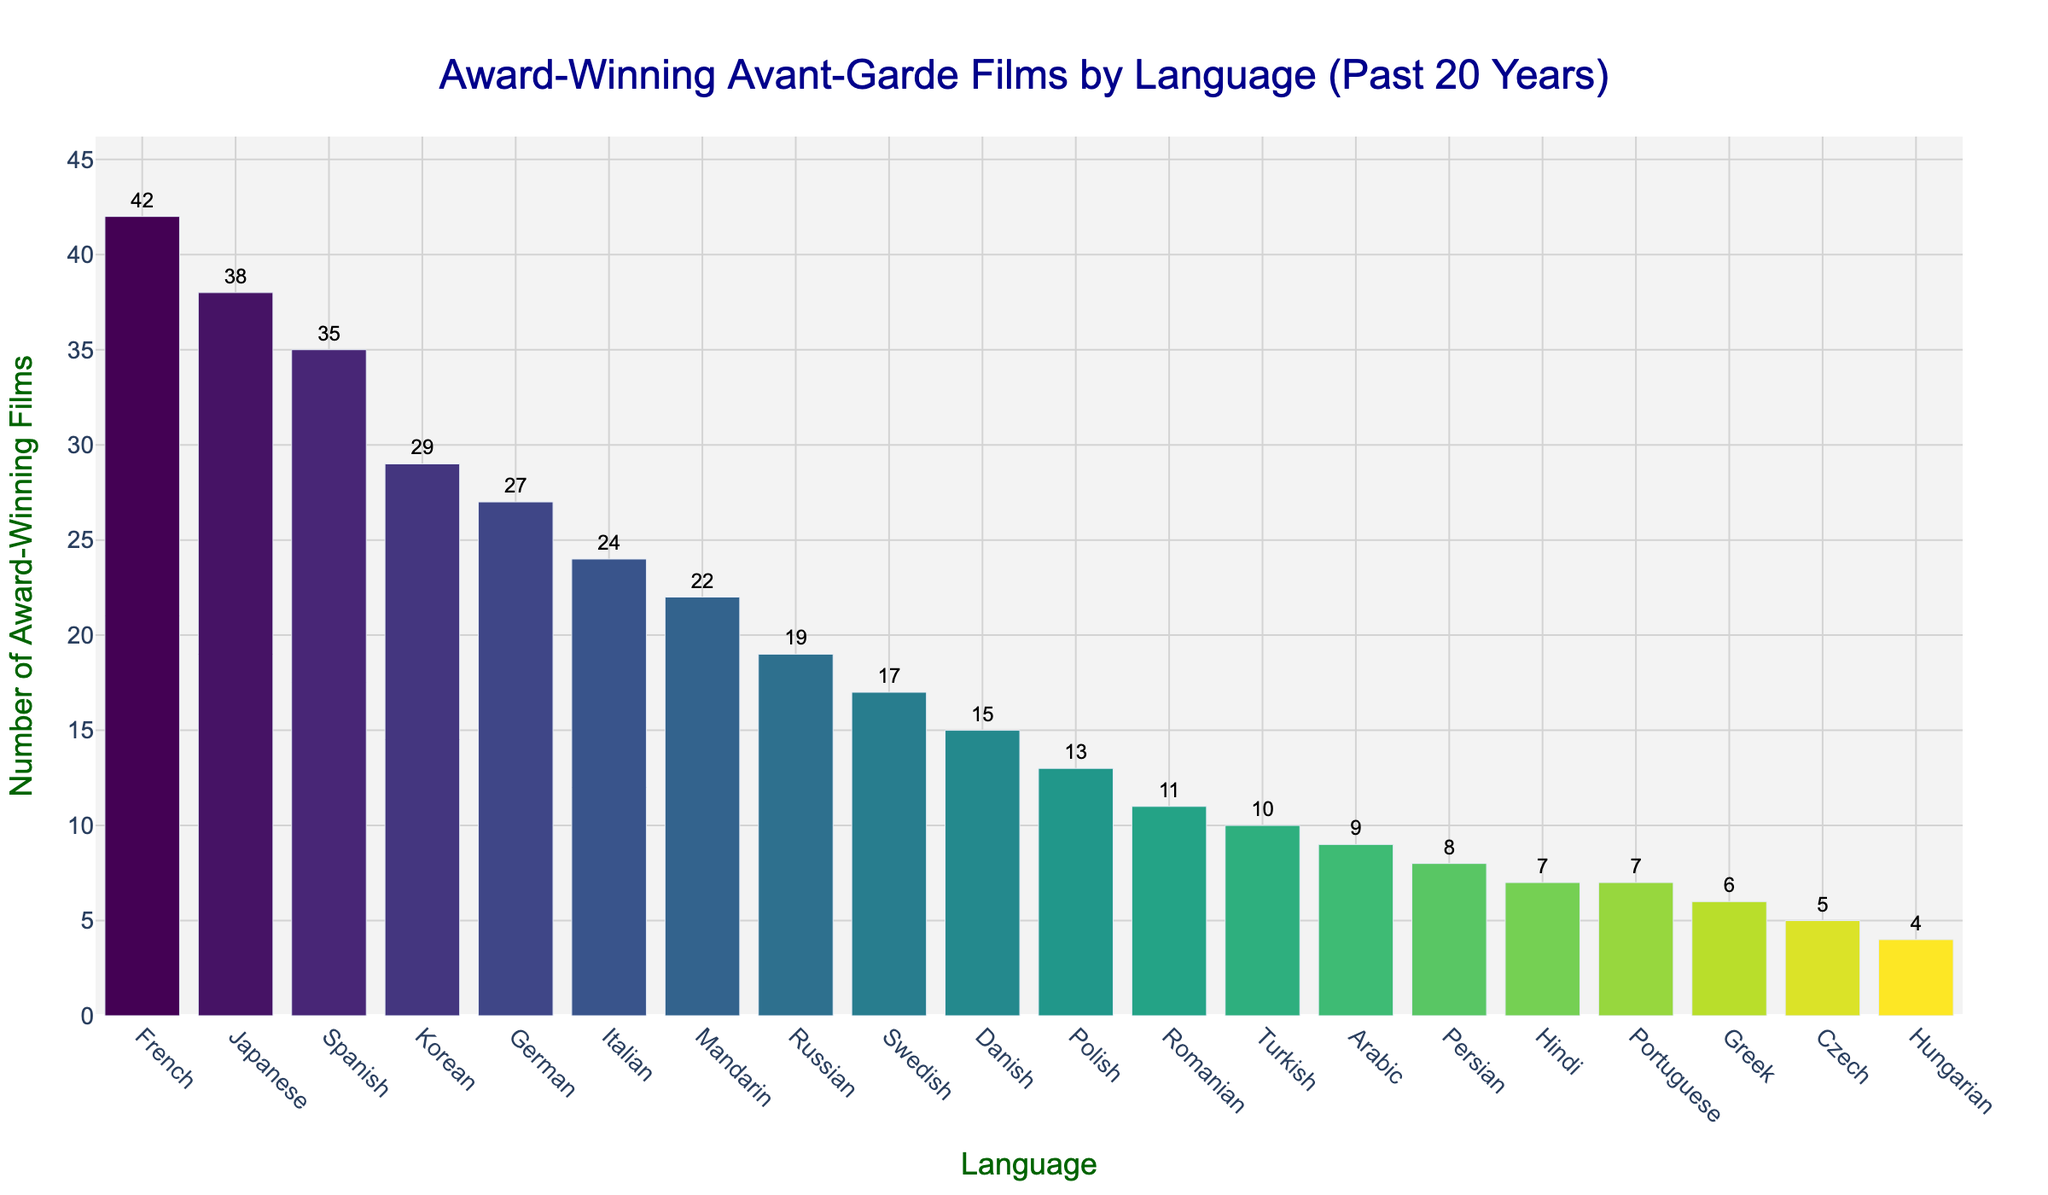What's the total number of award-winning films from French and Japanese cinema? To find the total, sum the number of award-winning films from French (42) and Japanese (38) cinema. 42 + 38 = 80
Answer: 80 Which language has the highest number of award-winning avant-garde films? Simply look for the highest bar in the chart. The bar for French is the highest with 42 films.
Answer: French How many more award-winning films are there in Spanish compared to Hungarian? Subtract the number of award-winning films in Hungarian (4) from Spanish (35). 35 - 4 = 31
Answer: 31 Which languages have an equal number of award-winning films? By looking at the lengths of the bars and the numerical values, we see that Hindi and Portuguese each have 7 award-winning films.
Answer: Hindi and Portuguese Is the number of award-winning films in Korean cinema greater than in German cinema? Compare the heights of the bars for Korean (29) and German (27) films. 29 > 27, so yes, Korean has more.
Answer: Yes What's the average number of award-winning films for the languages listed? Add the number of films for all languages and divide by the number of languages: (42 + 38 + 35 + 29 + 27 + 24 + 22 + 19 + 17 + 15 + 13 + 11 + 10 + 9 + 8 + 7 + 7 + 6 + 5 + 4) / 20 = 372 / 20 = 18.6
Answer: 18.6 If you combined the number of award-winning films in both Swedish and Danish cinema, would it surpass the number of films in French cinema? Sum the number of films in Swedish (17) and Danish (15), and then compare it to the number of films in French (42). 17 + 15 = 32, which is less than 42, so no.
Answer: No Which languages have fewer than 10 award-winning films? Look for bars whose height corresponds to a value less than 10: Turkish (10), Arabic (9), Persian (8), Hindi (7), Portuguese (7), Greek (6), Czech (5), Hungarian (4).
Answer: Arabic, Persian, Hindi, Portuguese, Greek, Czech, Hungarian Are there more award-winning films in Italian cinema than in Mandarin cinema? Compare the heights of the bars for Italian (24) and Mandarin (22) films. 24 > 22, so yes, Italian has more.
Answer: Yes 